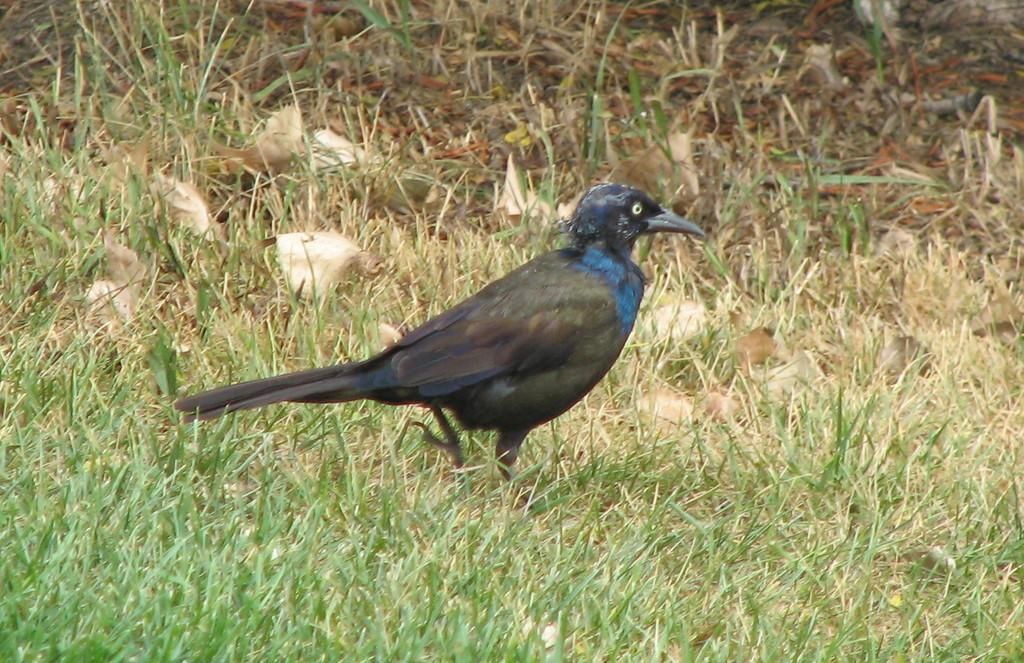Where was the image taken? The image was taken outdoors. What type of surface can be seen on the ground in the image? The ground with grass can be seen in the image. What additional elements are present on the ground? Dry leaves are present on the ground in the image. What type of animal can be seen on the ground in the image? There is a bird on the ground in the image. How many bikes are parked next to the bird in the image? There are no bikes present in the image; it only features a bird on the ground. What type of joke is being told by the bird in the image? There is no indication of a joke being told in the image; it simply shows a bird on the ground. 